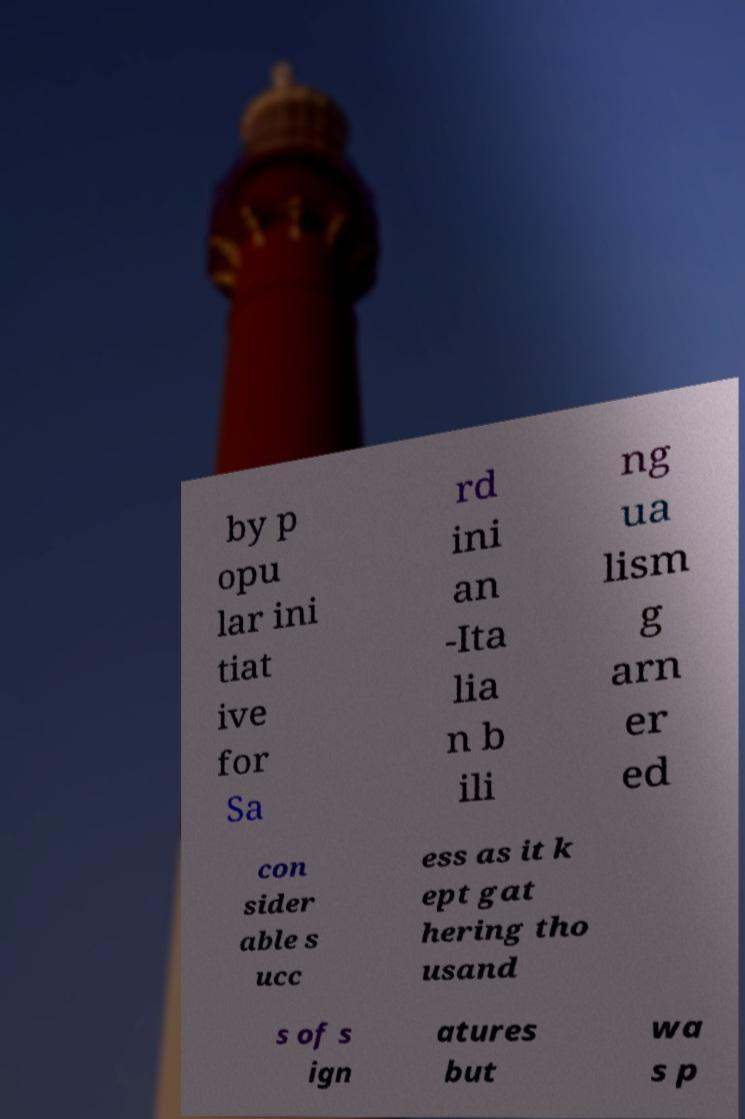Could you assist in decoding the text presented in this image and type it out clearly? by p opu lar ini tiat ive for Sa rd ini an -Ita lia n b ili ng ua lism g arn er ed con sider able s ucc ess as it k ept gat hering tho usand s of s ign atures but wa s p 